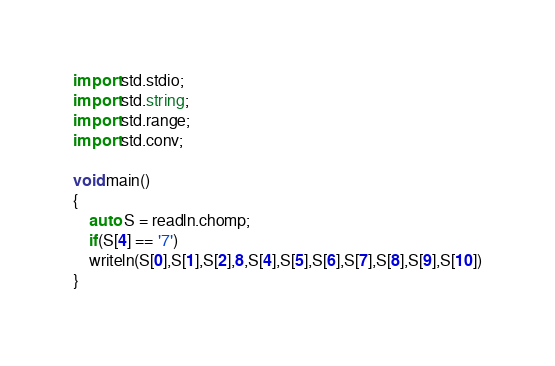<code> <loc_0><loc_0><loc_500><loc_500><_D_>import std.stdio;
import std.string;
import std.range;
import std.conv;

void main()
{
	auto S = readln.chomp;
	if(S[4] == '7')
	writeln(S[0],S[1],S[2],8,S[4],S[5],S[6],S[7],S[8],S[9],S[10])
}</code> 